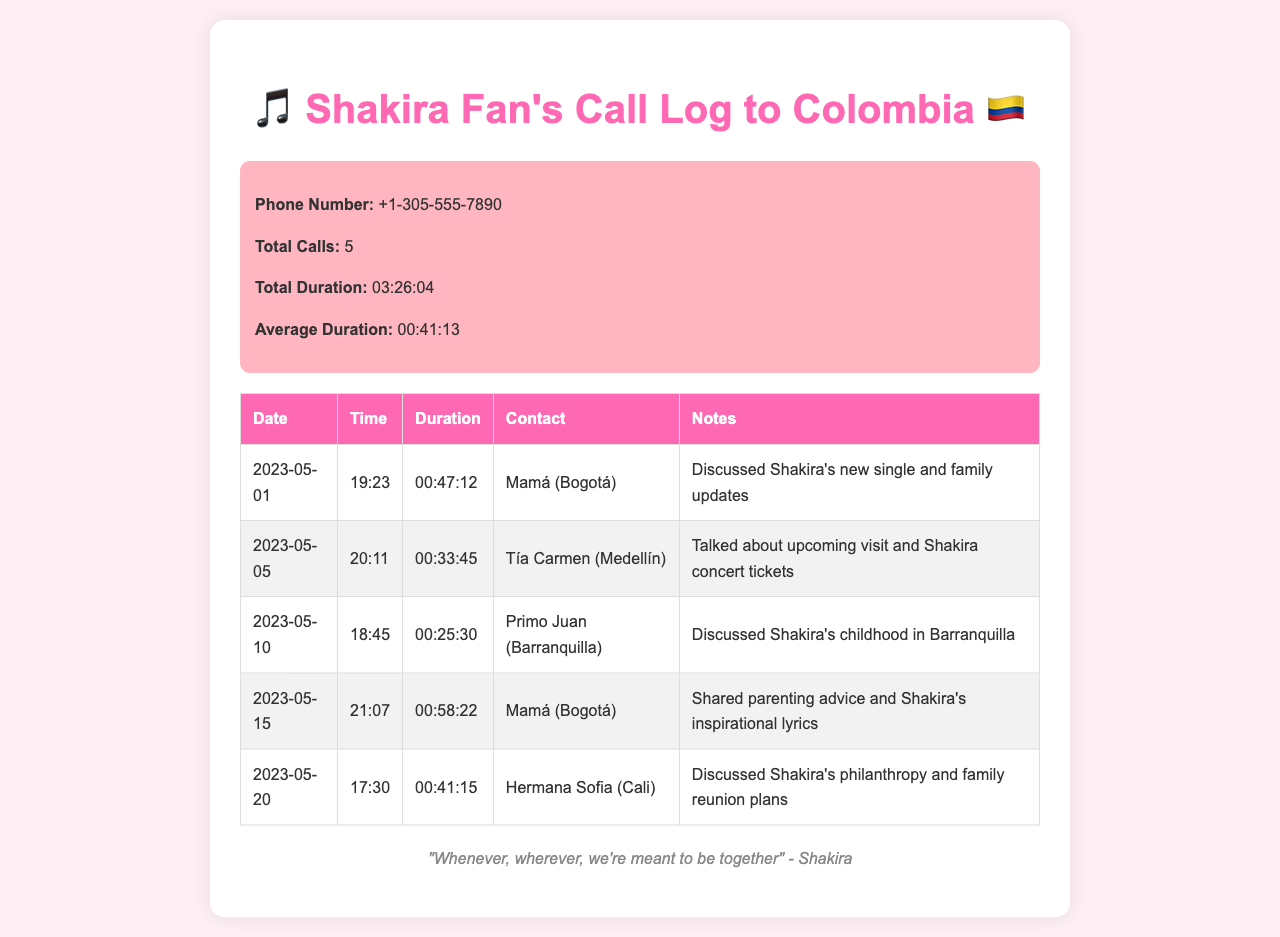what is the phone number? The phone number is clearly stated at the beginning of the summary section of the document.
Answer: +1-305-555-7890 how many calls were made? The total number of calls is noted in the summary section of the document.
Answer: 5 what was the longest call duration? The duration of each call is listed, and the longest call can be identified from these entries.
Answer: 00:58:22 who was the caller on May 10th? The contact for the call on May 10th is specified in the call log section.
Answer: Primo Juan (Barranquilla) what topics were discussed with Mamá during the calls? The notes for both calls to Mamá elaborate on the topics of discussion reflecting family and Shakira's music.
Answer: Shakira's new single and family updates, parenting advice and Shakira's inspirational lyrics how many minutes of calls were made in total? The total duration is summed from the individual calls listed in the document.
Answer: 206 minutes which contact discussed Shakira's philanthropy? The notes section mentions specific topics associated with each contact during the calls.
Answer: Hermana Sofia (Cali) what was the average duration of the calls? The document calculates the average duration based on total duration and number of calls.
Answer: 00:41:13 